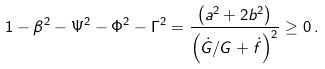Convert formula to latex. <formula><loc_0><loc_0><loc_500><loc_500>1 - \beta ^ { 2 } - \Psi ^ { 2 } - \Phi ^ { 2 } - \Gamma ^ { 2 } = \frac { \left ( a ^ { 2 } + 2 b ^ { 2 } \right ) } { \left ( \dot { G } / G + \dot { f } \right ) ^ { 2 } } \geq 0 \, .</formula> 